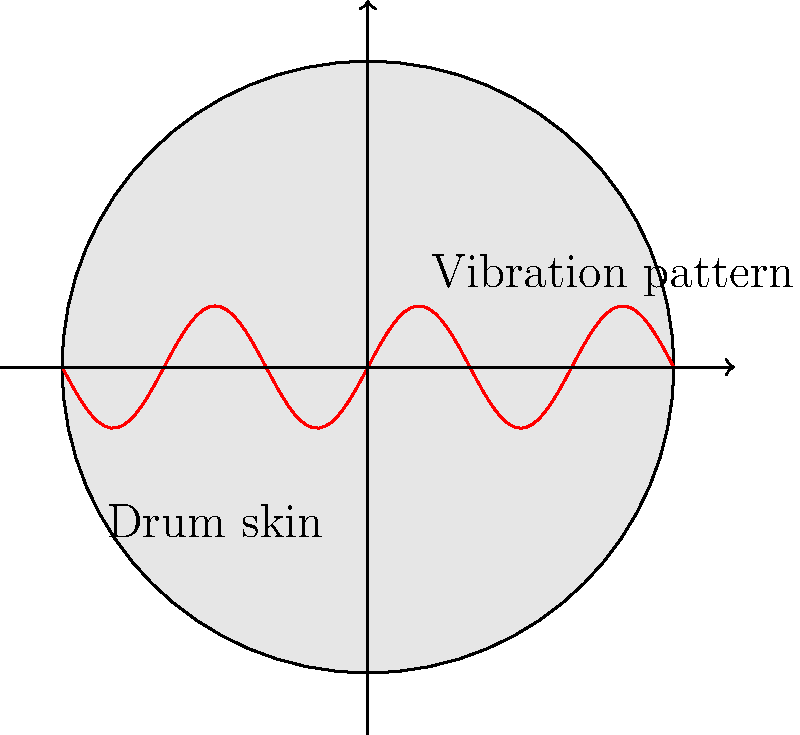A traditional Kenyan drum, similar to the "ngoma" used in cultural ceremonies, has a circular membrane with a diameter of 40 cm. When struck, it produces a fundamental frequency of 150 Hz. If the tension in the membrane is increased by 20%, what will be the new fundamental frequency of the drum? Assume the mass of the membrane remains constant. To solve this problem, we'll use the relationship between frequency, tension, and other properties of a vibrating membrane. The fundamental frequency of a circular membrane is given by:

$$ f = \frac{1}{2\pi r}\sqrt{\frac{T}{\sigma}} $$

Where:
$f$ is the frequency
$r$ is the radius of the membrane
$T$ is the tension in the membrane
$\sigma$ is the mass per unit area of the membrane

Step 1: We don't need to calculate the actual tension or mass per unit area. We only need to consider how the frequency changes when tension changes.

Step 2: The relationship between frequency and tension can be simplified to:

$$ f \propto \sqrt{T} $$

Step 3: If the tension increases by 20%, the new tension is 1.2 times the original tension.

Step 4: The new frequency will be:

$$ f_{new} = f_{original} \sqrt{\frac{T_{new}}{T_{original}}} = f_{original} \sqrt{1.2} $$

Step 5: Calculate the new frequency:

$$ f_{new} = 150 \text{ Hz} \times \sqrt{1.2} \approx 164.3 \text{ Hz} $$
Answer: 164.3 Hz 